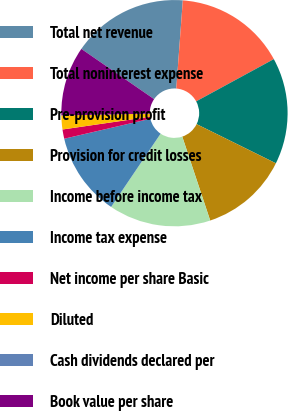Convert chart to OTSL. <chart><loc_0><loc_0><loc_500><loc_500><pie_chart><fcel>Total net revenue<fcel>Total noninterest expense<fcel>Pre-provision profit<fcel>Provision for credit losses<fcel>Income before income tax<fcel>Income tax expense<fcel>Net income per share Basic<fcel>Diluted<fcel>Cash dividends declared per<fcel>Book value per share<nl><fcel>16.56%<fcel>15.89%<fcel>15.23%<fcel>12.58%<fcel>14.57%<fcel>11.92%<fcel>1.32%<fcel>1.99%<fcel>0.0%<fcel>9.93%<nl></chart> 